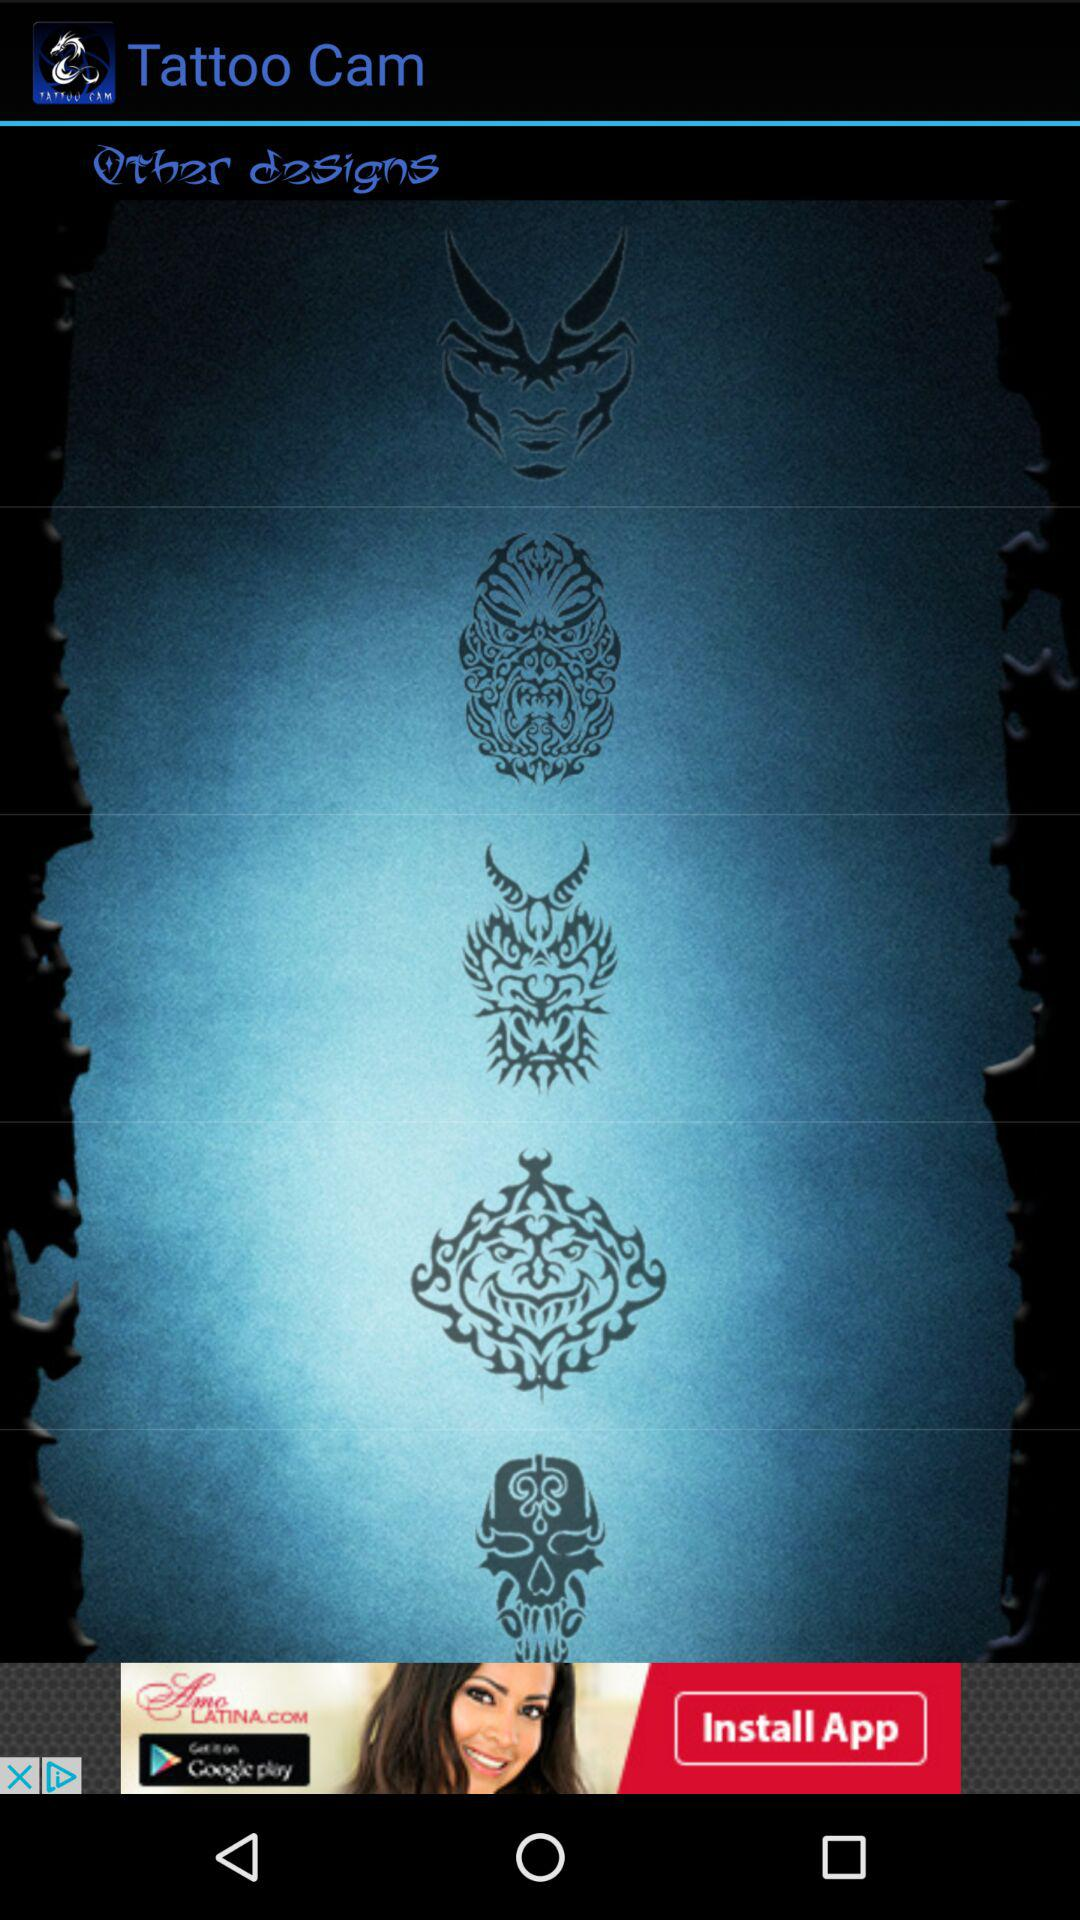What is the application name? The application name is "Tattoo Cam". 